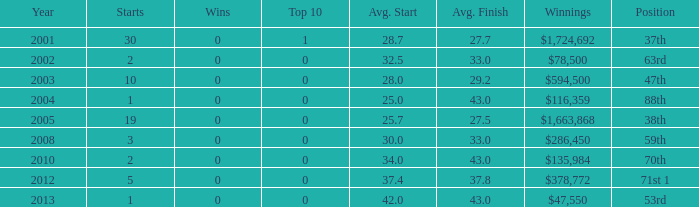How many starts are needed for an average finish greater than 43? None. 